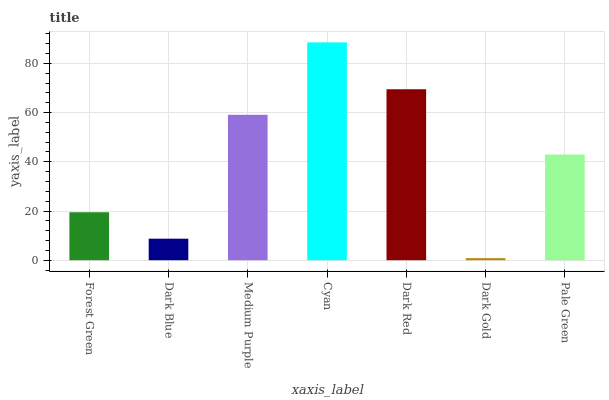Is Dark Gold the minimum?
Answer yes or no. Yes. Is Cyan the maximum?
Answer yes or no. Yes. Is Dark Blue the minimum?
Answer yes or no. No. Is Dark Blue the maximum?
Answer yes or no. No. Is Forest Green greater than Dark Blue?
Answer yes or no. Yes. Is Dark Blue less than Forest Green?
Answer yes or no. Yes. Is Dark Blue greater than Forest Green?
Answer yes or no. No. Is Forest Green less than Dark Blue?
Answer yes or no. No. Is Pale Green the high median?
Answer yes or no. Yes. Is Pale Green the low median?
Answer yes or no. Yes. Is Dark Blue the high median?
Answer yes or no. No. Is Dark Blue the low median?
Answer yes or no. No. 